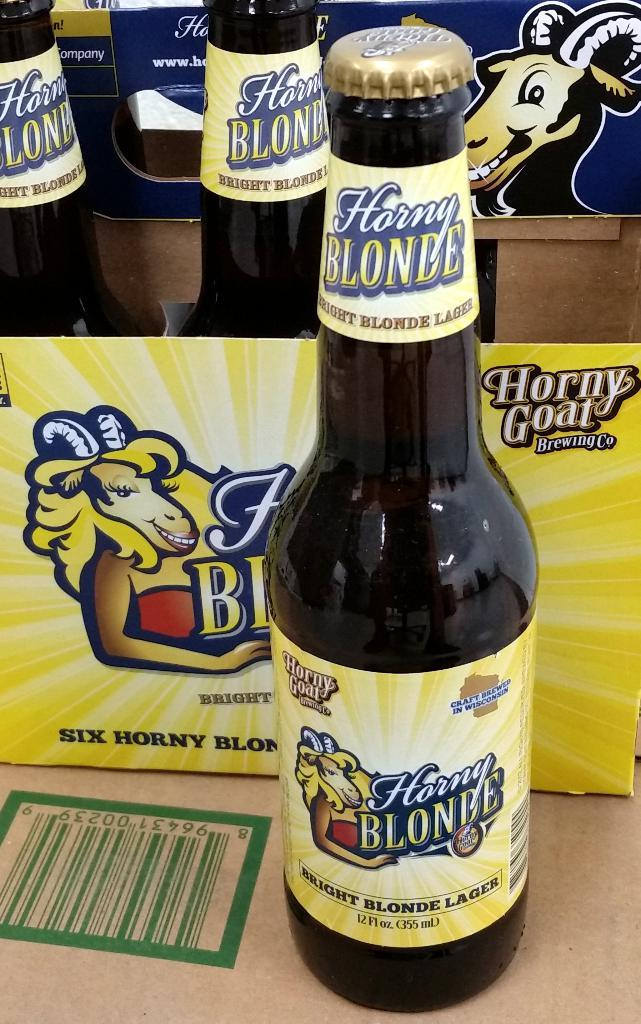<image>
Describe the image concisely. A bottle of beer sitting in front of a six pack, the bottle says Horny Blonde. 